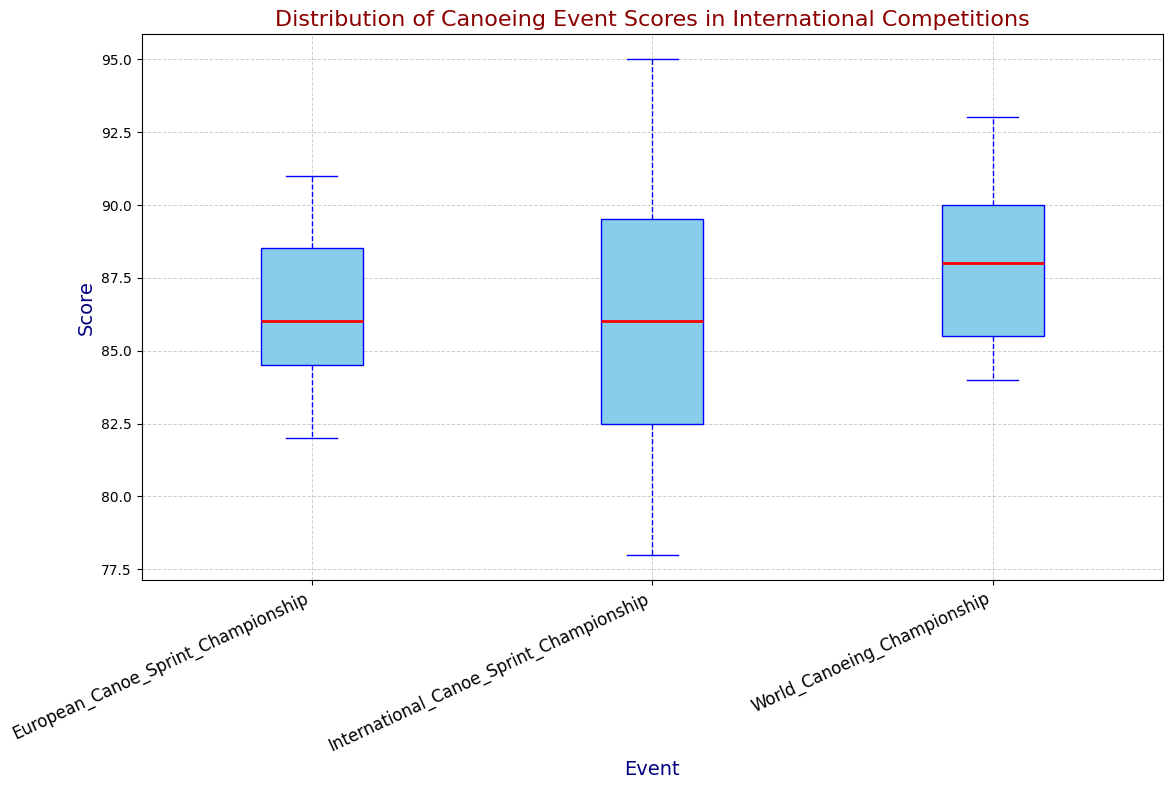What is the median score of the International Canoe Sprint Championship? To find the median score, we need to locate the midpoint value when the scores are ordered. The scores are: 78, 79, 80, 82, 83, 84, 85, 86, 87, 88, 89, 90, 91, 93, 95. The middle value, or 8th score, is 86.
Answer: 86 Which event has the highest median score? Comparing the median scores of the events: International Canoe Sprint Championship (86), World Canoeing Championship (88), and European Canoe Sprint Championship (86). The highest median is from the World Canoeing Championship.
Answer: World Canoeing Championship Do any events share the same median score? We check if the median scores of any of the events are equal. The International Canoe Sprint Championship and the European Canoe Sprint Championship both have a median score of 86.
Answer: Yes How does the interquartile range (IQR) of the World Canoeing Championship compare to the International Canoe Sprint Championship? The IQR is the difference between the 75th and 25th percentile values. For the World Canoeing Championship, we consider the quartile values from the box plot. Similarly, we do this for the International Canoe Sprint Championship. We infer from the box plot that the World Canoeing Championship has a narrower IQR.
Answer: Narrower Which event has the widest range of scores? The range is determined by the difference between the maximum and minimum scores. By examining the upper and lower whiskers, the event with the most spread-out whiskers will have the widest range, which appears to be the International Canoe Sprint Championship.
Answer: International Canoe Sprint Championship What is the lowest score recorded in the European Canoe Sprint Championship? Observing the lower whisker of the European Canoe Sprint Championship box plot, the minimum score is identified as the bottom end.
Answer: 82 What is the difference between the medians of the World Canoeing Championship and the European Canoe Sprint Championship? The median score for the World Canoeing Championship is 88, and for the European Canoe Sprint Championship, it is 86. The difference between these medians is calculated as 88 - 86.
Answer: 2 Which event seems to have the most consistent scoring based on the box plot? Consistency can be inferred from the tightness of the IQR and shorter whiskers. The World Canoeing Championship shows the most consistency as its box plot and whiskers are the shortest.
Answer: World Canoeing Championship Is there any outlier in any of the events according to the box plot? Outliers would be represented as individual points outside the whiskers. By examining the plots, no standalone points are observed beyond the whiskers.
Answer: No 